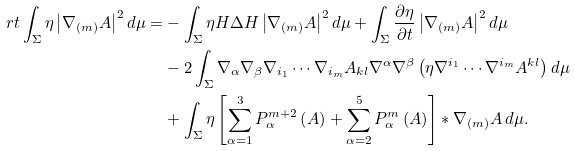Convert formula to latex. <formula><loc_0><loc_0><loc_500><loc_500>\ r { t } \int _ { \Sigma } \eta \left | \nabla _ { ( m ) } A \right | ^ { 2 } d \mu = & - \int _ { \Sigma } \eta H \Delta H \left | \nabla _ { ( m ) } A \right | ^ { 2 } d \mu + \int _ { \Sigma } \frac { \partial \eta } { \partial t } \left | \nabla _ { ( m ) } A \right | ^ { 2 } d \mu \\ & - 2 \int _ { \Sigma } \nabla _ { \alpha } \nabla _ { \beta } \nabla _ { i _ { 1 } } \cdots \nabla _ { i _ { m } } A _ { k l } \nabla ^ { \alpha } \nabla ^ { \beta } \left ( \eta \nabla ^ { i _ { 1 } } \cdots \nabla ^ { i _ { m } } A ^ { k l } \right ) d \mu \\ & + \int _ { \Sigma } \eta \left [ \sum _ { \alpha = 1 } ^ { 3 } P _ { \alpha } ^ { m + 2 } \left ( A \right ) + \sum _ { \alpha = 2 } ^ { 5 } P _ { \alpha } ^ { m } \left ( A \right ) \right ] * \nabla _ { ( m ) } A \, d \mu .</formula> 